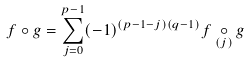Convert formula to latex. <formula><loc_0><loc_0><loc_500><loc_500>f \circ g = \sum _ { j = 0 } ^ { p - 1 } ( - 1 ) ^ { ( p - 1 - j ) ( q - 1 ) } f \underset { ( j ) } { \circ } g</formula> 